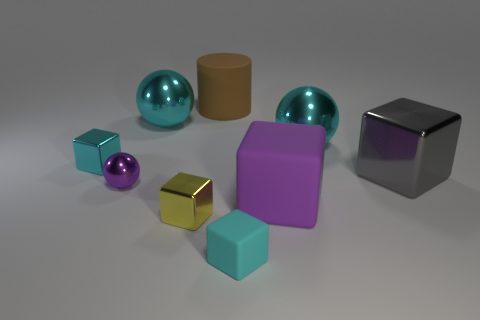The large thing on the right side of the big cyan shiny sphere that is right of the large purple rubber object is made of what material?
Ensure brevity in your answer.  Metal. Is the number of shiny cubes that are behind the large metal cube greater than the number of yellow metal spheres?
Your answer should be very brief. Yes. Is there a small purple metallic block?
Provide a short and direct response. No. What color is the sphere to the right of the large cylinder?
Provide a short and direct response. Cyan. There is a gray cube that is the same size as the purple matte object; what is it made of?
Make the answer very short. Metal. How many other objects are the same material as the tiny sphere?
Your answer should be compact. 5. There is a shiny ball that is both on the left side of the matte cylinder and behind the large gray object; what is its color?
Provide a short and direct response. Cyan. What number of things are cyan metal objects that are on the left side of the purple rubber block or tiny purple balls?
Provide a short and direct response. 3. What number of other objects are the same color as the small metal ball?
Make the answer very short. 1. Are there the same number of brown cylinders that are on the right side of the gray block and things?
Ensure brevity in your answer.  No. 